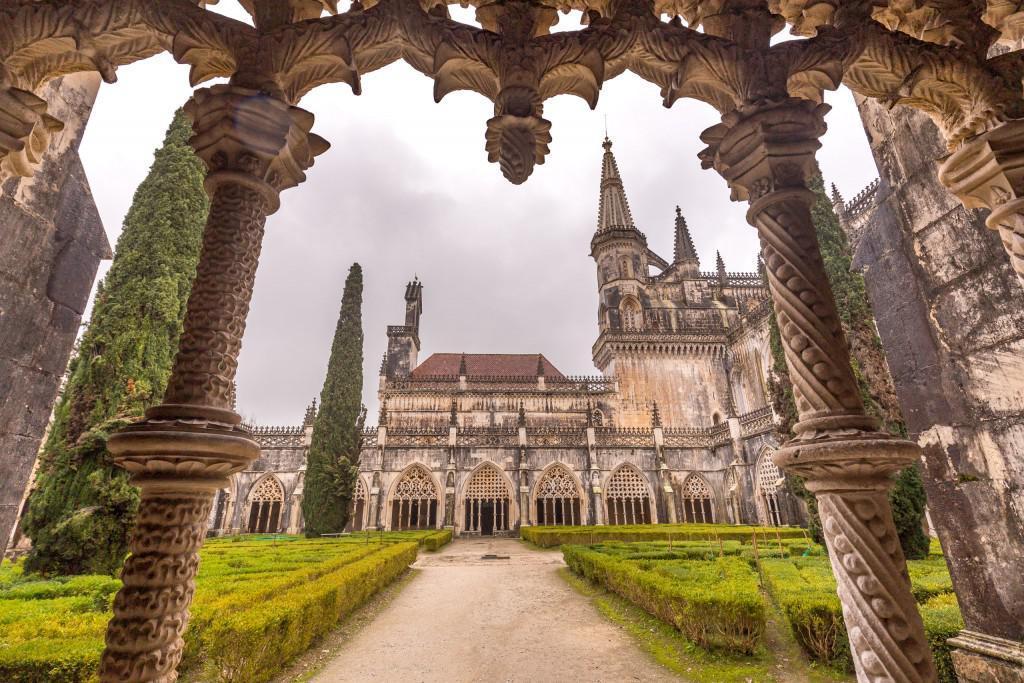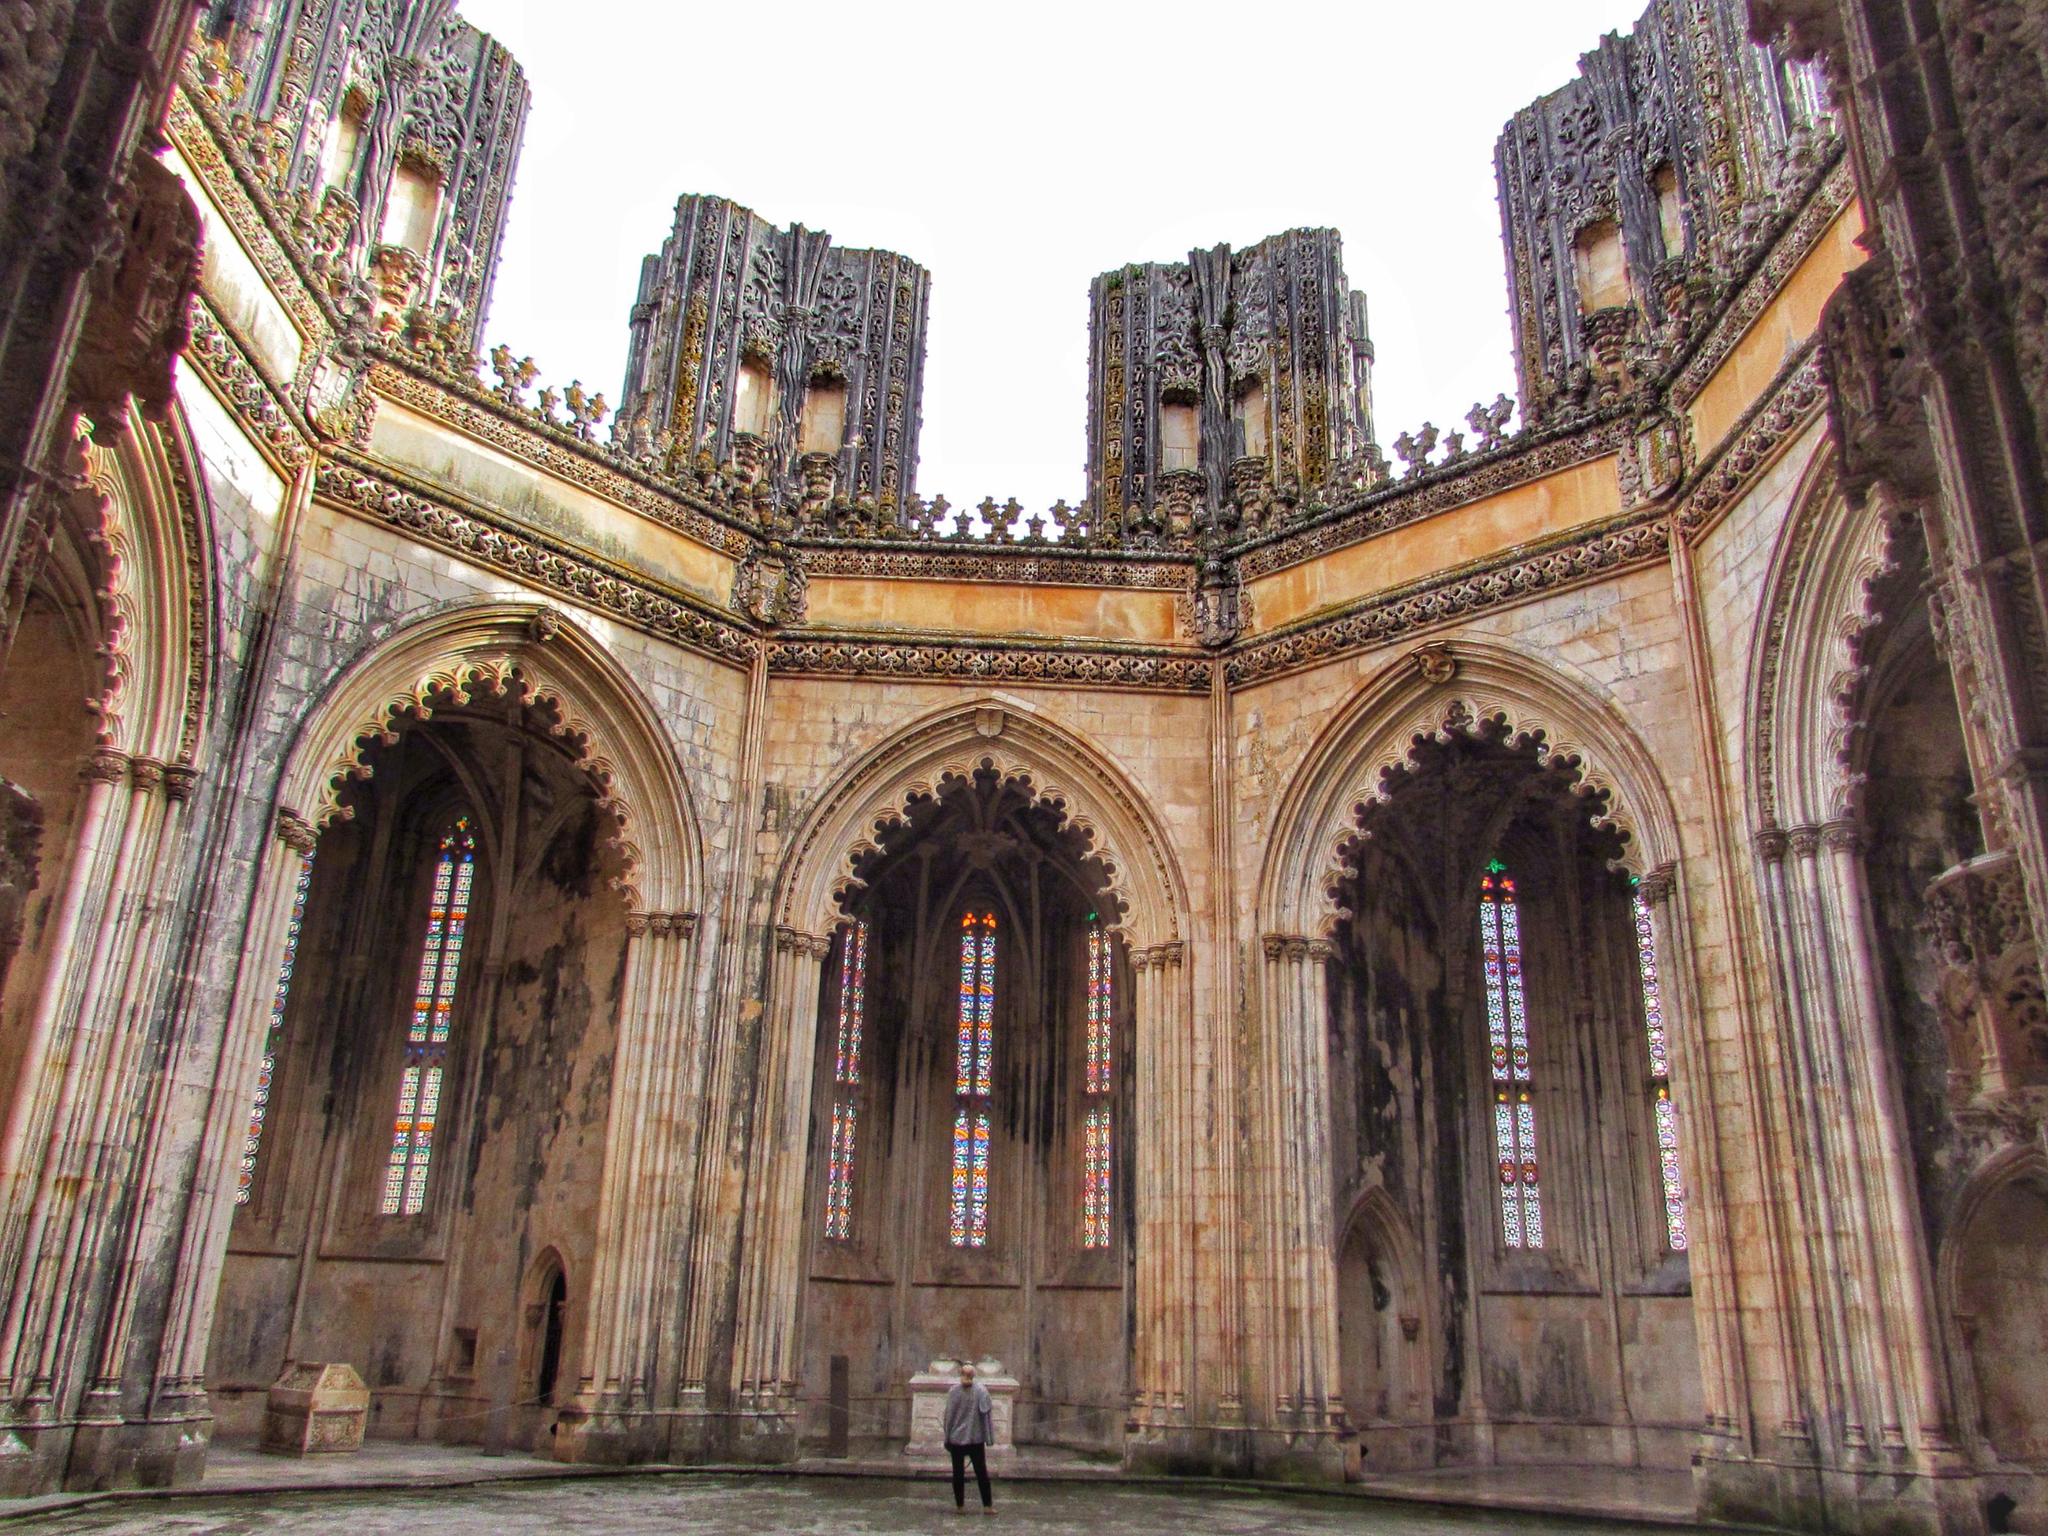The first image is the image on the left, the second image is the image on the right. Given the left and right images, does the statement "An image shows multiple people standing in front of a massive archway." hold true? Answer yes or no. No. The first image is the image on the left, the second image is the image on the right. Considering the images on both sides, is "The image on the left doesn't show the turrets of the castle." valid? Answer yes or no. No. 